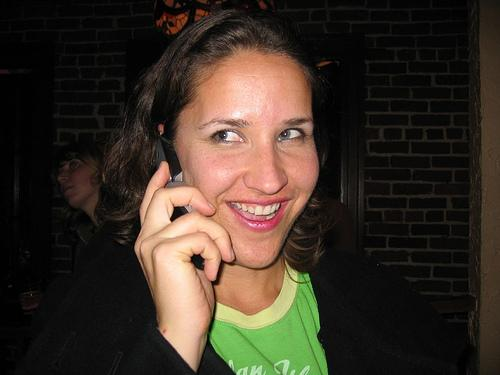Which hand is she using to hold the phone?

Choices:
A) left
B) both
C) right
D) neither right 